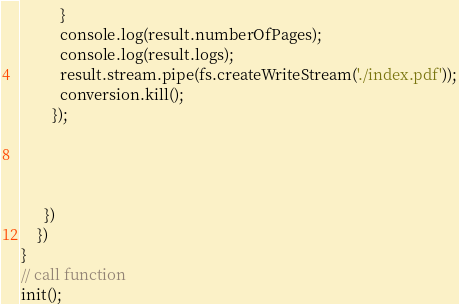Convert code to text. <code><loc_0><loc_0><loc_500><loc_500><_JavaScript_>          }
          console.log(result.numberOfPages);
          console.log(result.logs);
          result.stream.pipe(fs.createWriteStream('./index.pdf'));
          conversion.kill(); 
        });




      })
    })
}
// call function
init();


</code> 